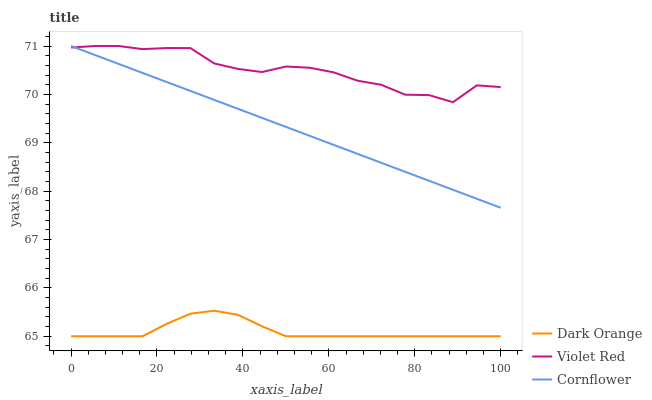Does Dark Orange have the minimum area under the curve?
Answer yes or no. Yes. Does Violet Red have the maximum area under the curve?
Answer yes or no. Yes. Does Cornflower have the minimum area under the curve?
Answer yes or no. No. Does Cornflower have the maximum area under the curve?
Answer yes or no. No. Is Cornflower the smoothest?
Answer yes or no. Yes. Is Violet Red the roughest?
Answer yes or no. Yes. Is Violet Red the smoothest?
Answer yes or no. No. Is Cornflower the roughest?
Answer yes or no. No. Does Dark Orange have the lowest value?
Answer yes or no. Yes. Does Cornflower have the lowest value?
Answer yes or no. No. Does Cornflower have the highest value?
Answer yes or no. Yes. Is Dark Orange less than Violet Red?
Answer yes or no. Yes. Is Cornflower greater than Dark Orange?
Answer yes or no. Yes. Does Cornflower intersect Violet Red?
Answer yes or no. Yes. Is Cornflower less than Violet Red?
Answer yes or no. No. Is Cornflower greater than Violet Red?
Answer yes or no. No. Does Dark Orange intersect Violet Red?
Answer yes or no. No. 